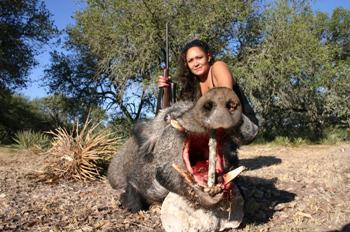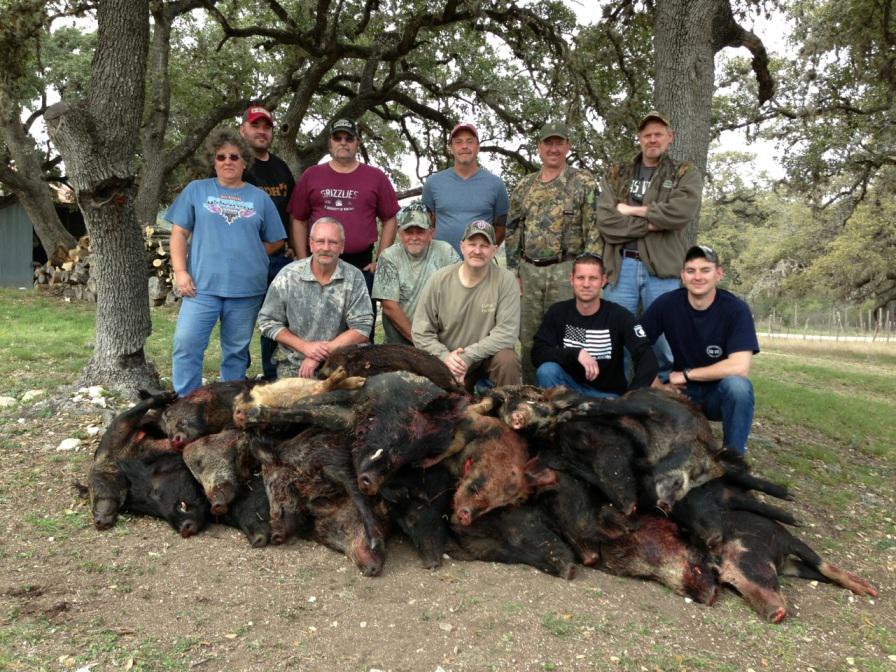The first image is the image on the left, the second image is the image on the right. Considering the images on both sides, is "In at least one image there is a person kneeing over a dead boar with its mouth hanging open." valid? Answer yes or no. Yes. The first image is the image on the left, the second image is the image on the right. Analyze the images presented: Is the assertion "there is a person crouched down behind a dead boar on brown grass" valid? Answer yes or no. Yes. 